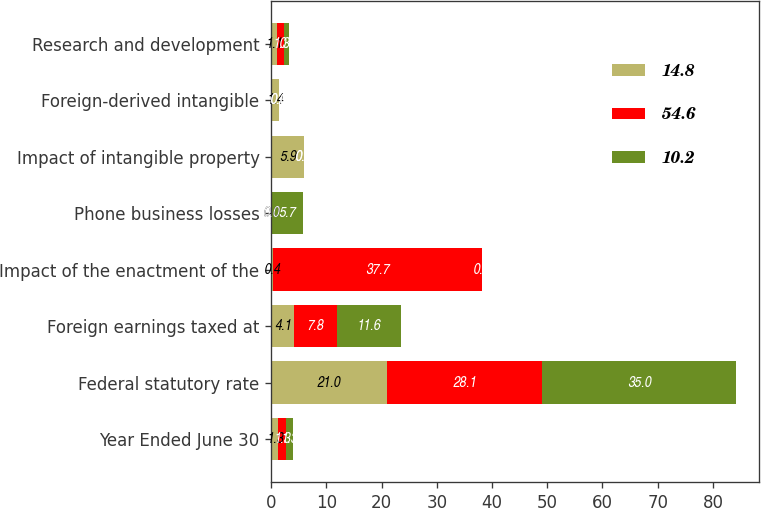<chart> <loc_0><loc_0><loc_500><loc_500><stacked_bar_chart><ecel><fcel>Year Ended June 30<fcel>Federal statutory rate<fcel>Foreign earnings taxed at<fcel>Impact of the enactment of the<fcel>Phone business losses<fcel>Impact of intangible property<fcel>Foreign-derived intangible<fcel>Research and development<nl><fcel>14.8<fcel>1.3<fcel>21<fcel>4.1<fcel>0.4<fcel>0<fcel>5.9<fcel>1.4<fcel>1.1<nl><fcel>54.6<fcel>1.3<fcel>28.1<fcel>7.8<fcel>37.7<fcel>0<fcel>0<fcel>0<fcel>1.3<nl><fcel>10.2<fcel>1.3<fcel>35<fcel>11.6<fcel>0<fcel>5.7<fcel>0<fcel>0<fcel>0.9<nl></chart> 